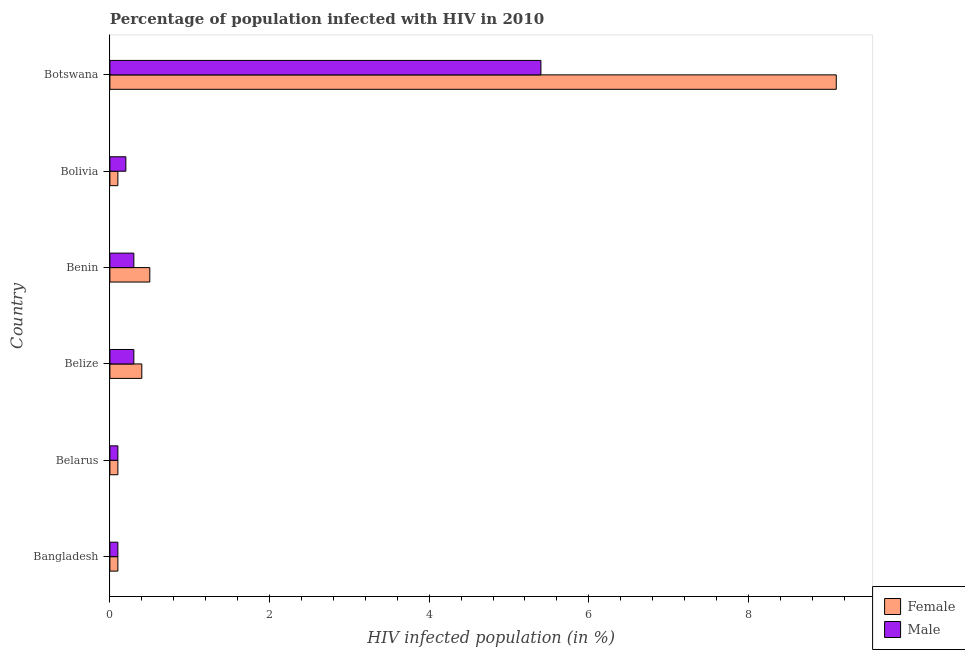How many groups of bars are there?
Ensure brevity in your answer.  6. Are the number of bars per tick equal to the number of legend labels?
Ensure brevity in your answer.  Yes. How many bars are there on the 5th tick from the top?
Your response must be concise. 2. What is the label of the 2nd group of bars from the top?
Provide a short and direct response. Bolivia. What is the percentage of females who are infected with hiv in Botswana?
Offer a terse response. 9.1. Across all countries, what is the maximum percentage of females who are infected with hiv?
Give a very brief answer. 9.1. In which country was the percentage of females who are infected with hiv maximum?
Keep it short and to the point. Botswana. In which country was the percentage of males who are infected with hiv minimum?
Your answer should be very brief. Bangladesh. What is the average percentage of males who are infected with hiv per country?
Your response must be concise. 1.07. What is the difference between the percentage of females who are infected with hiv and percentage of males who are infected with hiv in Bolivia?
Your answer should be compact. -0.1. What is the ratio of the percentage of males who are infected with hiv in Bangladesh to that in Bolivia?
Your response must be concise. 0.5. Is the percentage of females who are infected with hiv in Belarus less than that in Belize?
Your answer should be very brief. Yes. In how many countries, is the percentage of females who are infected with hiv greater than the average percentage of females who are infected with hiv taken over all countries?
Ensure brevity in your answer.  1. What does the 1st bar from the bottom in Belarus represents?
Offer a very short reply. Female. How many bars are there?
Offer a terse response. 12. Are the values on the major ticks of X-axis written in scientific E-notation?
Your answer should be very brief. No. Does the graph contain any zero values?
Your answer should be very brief. No. Does the graph contain grids?
Your answer should be very brief. No. What is the title of the graph?
Give a very brief answer. Percentage of population infected with HIV in 2010. Does "Non-solid fuel" appear as one of the legend labels in the graph?
Make the answer very short. No. What is the label or title of the X-axis?
Offer a very short reply. HIV infected population (in %). What is the label or title of the Y-axis?
Give a very brief answer. Country. What is the HIV infected population (in %) in Female in Bangladesh?
Keep it short and to the point. 0.1. What is the HIV infected population (in %) in Female in Belize?
Your answer should be very brief. 0.4. What is the HIV infected population (in %) of Male in Belize?
Ensure brevity in your answer.  0.3. What is the HIV infected population (in %) of Male in Benin?
Your answer should be very brief. 0.3. Across all countries, what is the maximum HIV infected population (in %) of Female?
Your response must be concise. 9.1. Across all countries, what is the maximum HIV infected population (in %) in Male?
Provide a short and direct response. 5.4. Across all countries, what is the minimum HIV infected population (in %) of Female?
Your answer should be compact. 0.1. What is the total HIV infected population (in %) of Female in the graph?
Offer a very short reply. 10.3. What is the total HIV infected population (in %) in Male in the graph?
Provide a succinct answer. 6.4. What is the difference between the HIV infected population (in %) in Female in Bangladesh and that in Belize?
Provide a short and direct response. -0.3. What is the difference between the HIV infected population (in %) of Male in Bangladesh and that in Benin?
Your answer should be very brief. -0.2. What is the difference between the HIV infected population (in %) in Female in Bangladesh and that in Bolivia?
Make the answer very short. 0. What is the difference between the HIV infected population (in %) of Female in Bangladesh and that in Botswana?
Offer a very short reply. -9. What is the difference between the HIV infected population (in %) of Male in Bangladesh and that in Botswana?
Keep it short and to the point. -5.3. What is the difference between the HIV infected population (in %) of Female in Belarus and that in Belize?
Ensure brevity in your answer.  -0.3. What is the difference between the HIV infected population (in %) in Female in Belarus and that in Benin?
Make the answer very short. -0.4. What is the difference between the HIV infected population (in %) in Female in Belarus and that in Bolivia?
Provide a succinct answer. 0. What is the difference between the HIV infected population (in %) of Male in Belarus and that in Bolivia?
Offer a terse response. -0.1. What is the difference between the HIV infected population (in %) in Female in Belize and that in Benin?
Your response must be concise. -0.1. What is the difference between the HIV infected population (in %) in Female in Belize and that in Bolivia?
Your answer should be compact. 0.3. What is the difference between the HIV infected population (in %) of Male in Belize and that in Bolivia?
Provide a short and direct response. 0.1. What is the difference between the HIV infected population (in %) in Female in Belize and that in Botswana?
Offer a terse response. -8.7. What is the difference between the HIV infected population (in %) in Male in Benin and that in Bolivia?
Offer a terse response. 0.1. What is the difference between the HIV infected population (in %) in Male in Benin and that in Botswana?
Give a very brief answer. -5.1. What is the difference between the HIV infected population (in %) of Male in Bolivia and that in Botswana?
Provide a succinct answer. -5.2. What is the difference between the HIV infected population (in %) of Female in Bangladesh and the HIV infected population (in %) of Male in Belarus?
Ensure brevity in your answer.  0. What is the difference between the HIV infected population (in %) of Female in Belarus and the HIV infected population (in %) of Male in Belize?
Give a very brief answer. -0.2. What is the difference between the HIV infected population (in %) of Female in Belarus and the HIV infected population (in %) of Male in Bolivia?
Provide a succinct answer. -0.1. What is the difference between the HIV infected population (in %) in Female in Belarus and the HIV infected population (in %) in Male in Botswana?
Ensure brevity in your answer.  -5.3. What is the difference between the HIV infected population (in %) in Female in Belize and the HIV infected population (in %) in Male in Benin?
Make the answer very short. 0.1. What is the difference between the HIV infected population (in %) in Female in Belize and the HIV infected population (in %) in Male in Bolivia?
Your answer should be very brief. 0.2. What is the difference between the HIV infected population (in %) in Female in Benin and the HIV infected population (in %) in Male in Botswana?
Keep it short and to the point. -4.9. What is the difference between the HIV infected population (in %) of Female in Bolivia and the HIV infected population (in %) of Male in Botswana?
Your answer should be compact. -5.3. What is the average HIV infected population (in %) of Female per country?
Offer a terse response. 1.72. What is the average HIV infected population (in %) of Male per country?
Provide a succinct answer. 1.07. What is the difference between the HIV infected population (in %) in Female and HIV infected population (in %) in Male in Bangladesh?
Provide a short and direct response. 0. What is the difference between the HIV infected population (in %) in Female and HIV infected population (in %) in Male in Belarus?
Your response must be concise. 0. What is the difference between the HIV infected population (in %) in Female and HIV infected population (in %) in Male in Belize?
Ensure brevity in your answer.  0.1. What is the difference between the HIV infected population (in %) of Female and HIV infected population (in %) of Male in Bolivia?
Provide a succinct answer. -0.1. What is the ratio of the HIV infected population (in %) in Female in Bangladesh to that in Bolivia?
Provide a short and direct response. 1. What is the ratio of the HIV infected population (in %) in Female in Bangladesh to that in Botswana?
Offer a very short reply. 0.01. What is the ratio of the HIV infected population (in %) of Male in Bangladesh to that in Botswana?
Give a very brief answer. 0.02. What is the ratio of the HIV infected population (in %) of Male in Belarus to that in Belize?
Ensure brevity in your answer.  0.33. What is the ratio of the HIV infected population (in %) of Female in Belarus to that in Benin?
Offer a terse response. 0.2. What is the ratio of the HIV infected population (in %) of Male in Belarus to that in Benin?
Provide a succinct answer. 0.33. What is the ratio of the HIV infected population (in %) in Male in Belarus to that in Bolivia?
Make the answer very short. 0.5. What is the ratio of the HIV infected population (in %) in Female in Belarus to that in Botswana?
Offer a very short reply. 0.01. What is the ratio of the HIV infected population (in %) of Male in Belarus to that in Botswana?
Your answer should be very brief. 0.02. What is the ratio of the HIV infected population (in %) in Female in Belize to that in Benin?
Provide a succinct answer. 0.8. What is the ratio of the HIV infected population (in %) in Male in Belize to that in Benin?
Offer a terse response. 1. What is the ratio of the HIV infected population (in %) of Male in Belize to that in Bolivia?
Make the answer very short. 1.5. What is the ratio of the HIV infected population (in %) in Female in Belize to that in Botswana?
Your answer should be very brief. 0.04. What is the ratio of the HIV infected population (in %) of Male in Belize to that in Botswana?
Your answer should be compact. 0.06. What is the ratio of the HIV infected population (in %) in Female in Benin to that in Bolivia?
Ensure brevity in your answer.  5. What is the ratio of the HIV infected population (in %) of Female in Benin to that in Botswana?
Your answer should be very brief. 0.05. What is the ratio of the HIV infected population (in %) in Male in Benin to that in Botswana?
Your answer should be very brief. 0.06. What is the ratio of the HIV infected population (in %) in Female in Bolivia to that in Botswana?
Provide a short and direct response. 0.01. What is the ratio of the HIV infected population (in %) in Male in Bolivia to that in Botswana?
Give a very brief answer. 0.04. What is the difference between the highest and the second highest HIV infected population (in %) in Male?
Provide a succinct answer. 5.1. What is the difference between the highest and the lowest HIV infected population (in %) in Female?
Ensure brevity in your answer.  9. What is the difference between the highest and the lowest HIV infected population (in %) in Male?
Offer a terse response. 5.3. 